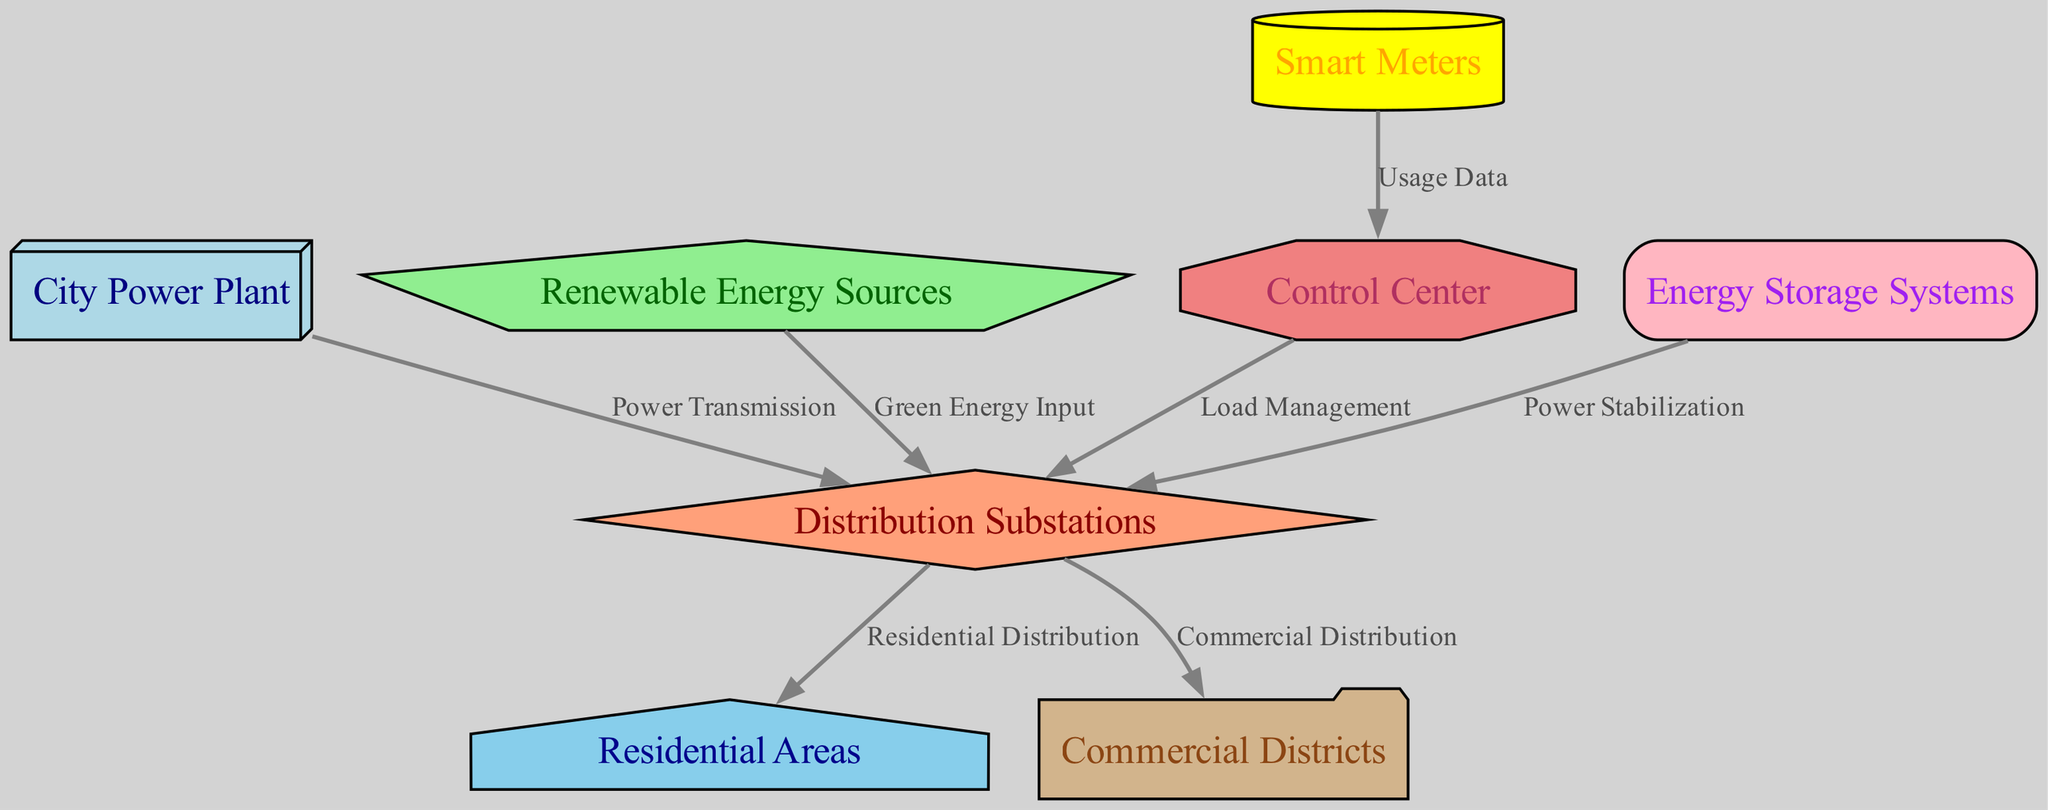What is the main power source in the diagram? The main power source is the "City Power Plant," as it is identified as the initiating node that connects to the distribution substations.
Answer: City Power Plant How many nodes are represented in the diagram? There are a total of eight nodes depicted in the diagram, representing different components of the smart grid system.
Answer: Eight What type of information do Smart Meters provide to the Control Center? Smart Meters provide "Usage Data" to the Control Center, which is critical for monitoring and managing energy consumption.
Answer: Usage Data Which components are connected to Distribution Substations? Distribution Substations are connected to Residential Areas and Commercial Districts for the purpose of power distribution.
Answer: Residential Areas, Commercial Districts What is the role of the Control Center in this smart grid system? The role of the Control Center is to manage load and ensure efficient distribution of power by interacting with various system components.
Answer: Load Management What links Renewable Energy Sources and Distribution Substations? The edge labeled "Green Energy Input" links Renewable Energy Sources and Distribution Substations, indicating the integration of renewable energies into the grid.
Answer: Green Energy Input Which system is responsible for stabilizing power supply? The "Energy Storage Systems" are responsible for stabilizing the power supply by managing excess energy and ensuring reliability.
Answer: Energy Storage Systems What type of data flows from the Smart Meters to the Control Center? The data that flows from Smart Meters to the Control Center is categorized as "Usage Data" which is essential for monitoring consumption.
Answer: Usage Data How does the diagram illustrate the relationship between the City Power Plant and Distribution Substations? The connection from the City Power Plant to Distribution Substations is labeled "Power Transmission," signifying the flow of electricity from the source to the distribution network.
Answer: Power Transmission 